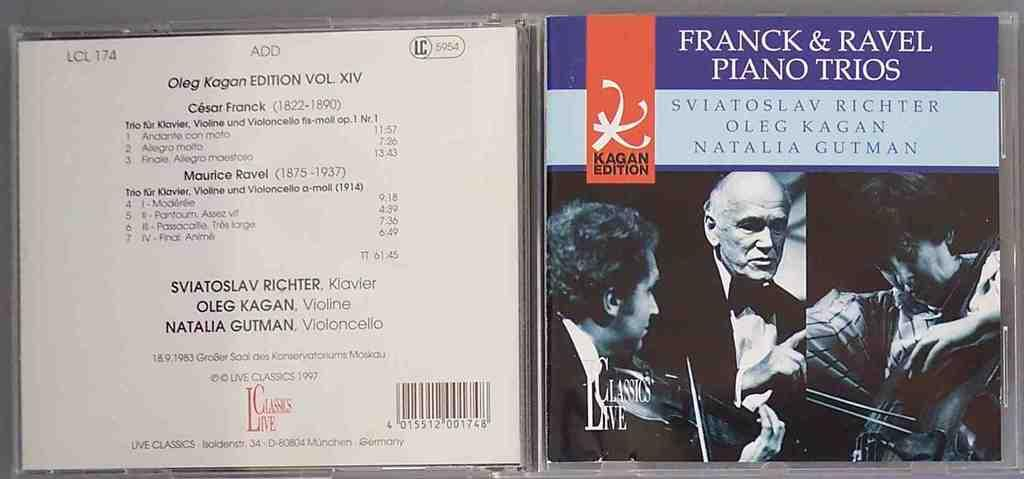Provide a one-sentence caption for the provided image. a CD with a FRANCK & RAVEL PIANO TRIOS music n it. 